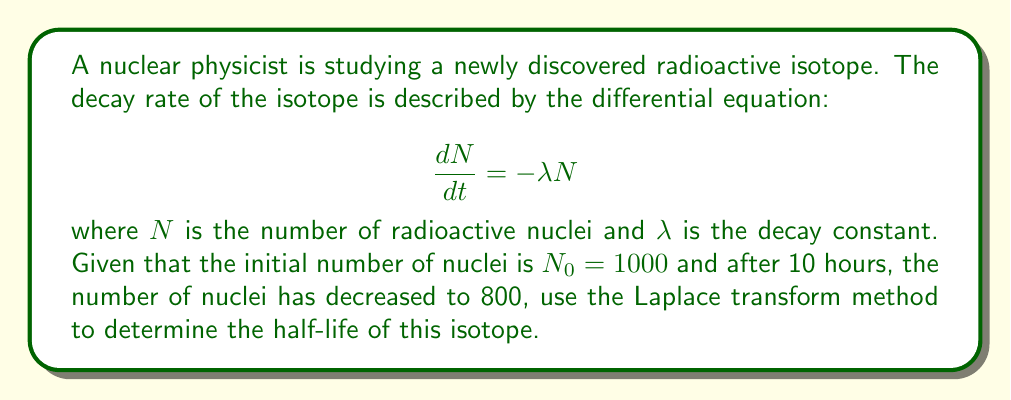Show me your answer to this math problem. Let's solve this problem step by step using Laplace transforms:

1) First, we need to apply the Laplace transform to both sides of the differential equation:

   $$\mathcal{L}\left\{\frac{dN}{dt}\right\} = \mathcal{L}\{-\lambda N\}$$

2) Using the properties of Laplace transforms, we get:

   $$s\mathcal{L}\{N\} - N_0 = -\lambda\mathcal{L}\{N\}$$

3) Let $\mathcal{L}\{N\} = X(s)$. Then:

   $$sX(s) - 1000 = -\lambda X(s)$$

4) Solving for $X(s)$:

   $$X(s) = \frac{1000}{s + \lambda}$$

5) The inverse Laplace transform of this is:

   $$N(t) = 1000e^{-\lambda t}$$

6) We know that after 10 hours, $N(10) = 800$. Let's use this information:

   $$800 = 1000e^{-10\lambda}$$

7) Solving for $\lambda$:

   $$e^{-10\lambda} = 0.8$$
   $$-10\lambda = \ln(0.8)$$
   $$\lambda = -\frac{\ln(0.8)}{10} \approx 0.0223 \text{ hr}^{-1}$$

8) The half-life $t_{1/2}$ is the time it takes for half of the nuclei to decay. It's related to $\lambda$ by:

   $$t_{1/2} = \frac{\ln(2)}{\lambda}$$

9) Substituting our value for $\lambda$:

   $$t_{1/2} = \frac{\ln(2)}{0.0223} \approx 31.08 \text{ hours}$$

Thus, the half-life of the isotope is approximately 31.08 hours.
Answer: The half-life of the radioactive isotope is approximately 31.08 hours. 